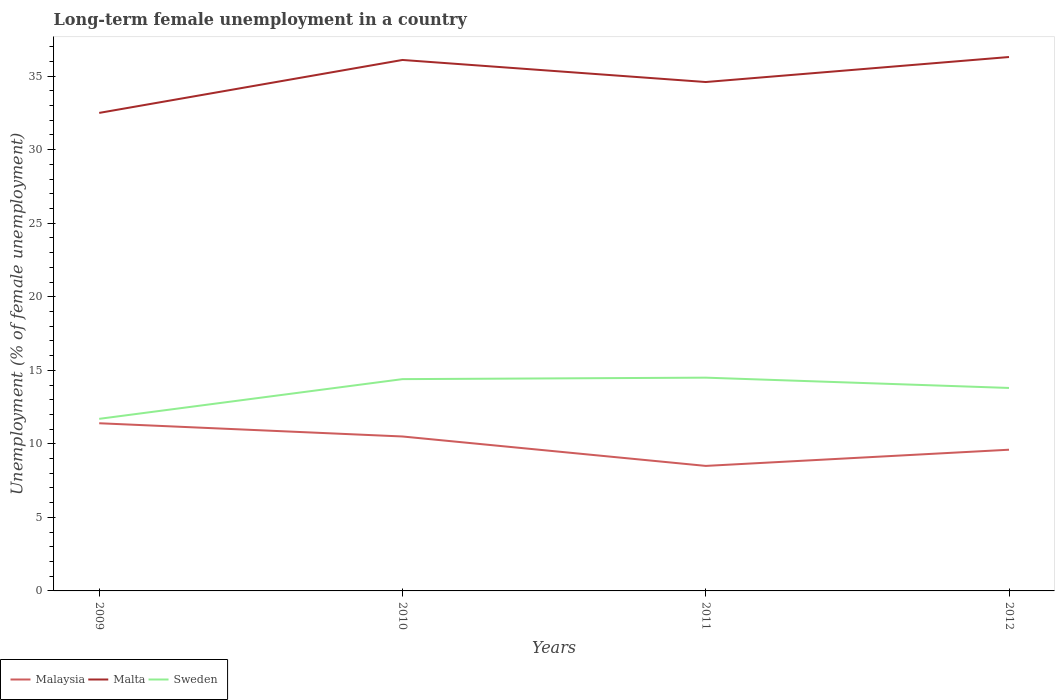Does the line corresponding to Malaysia intersect with the line corresponding to Malta?
Ensure brevity in your answer.  No. Is the number of lines equal to the number of legend labels?
Make the answer very short. Yes. Across all years, what is the maximum percentage of long-term unemployed female population in Malaysia?
Your answer should be compact. 8.5. In which year was the percentage of long-term unemployed female population in Malaysia maximum?
Offer a terse response. 2011. What is the total percentage of long-term unemployed female population in Sweden in the graph?
Provide a short and direct response. 0.7. What is the difference between the highest and the second highest percentage of long-term unemployed female population in Malta?
Ensure brevity in your answer.  3.8. What is the difference between the highest and the lowest percentage of long-term unemployed female population in Malaysia?
Give a very brief answer. 2. How many lines are there?
Give a very brief answer. 3. Are the values on the major ticks of Y-axis written in scientific E-notation?
Provide a short and direct response. No. Does the graph contain grids?
Make the answer very short. No. How are the legend labels stacked?
Your answer should be very brief. Horizontal. What is the title of the graph?
Your answer should be very brief. Long-term female unemployment in a country. Does "Samoa" appear as one of the legend labels in the graph?
Make the answer very short. No. What is the label or title of the X-axis?
Your response must be concise. Years. What is the label or title of the Y-axis?
Give a very brief answer. Unemployment (% of female unemployment). What is the Unemployment (% of female unemployment) in Malaysia in 2009?
Offer a terse response. 11.4. What is the Unemployment (% of female unemployment) of Malta in 2009?
Your answer should be very brief. 32.5. What is the Unemployment (% of female unemployment) of Sweden in 2009?
Ensure brevity in your answer.  11.7. What is the Unemployment (% of female unemployment) in Malta in 2010?
Make the answer very short. 36.1. What is the Unemployment (% of female unemployment) in Sweden in 2010?
Provide a succinct answer. 14.4. What is the Unemployment (% of female unemployment) of Malaysia in 2011?
Provide a succinct answer. 8.5. What is the Unemployment (% of female unemployment) in Malta in 2011?
Keep it short and to the point. 34.6. What is the Unemployment (% of female unemployment) of Malaysia in 2012?
Give a very brief answer. 9.6. What is the Unemployment (% of female unemployment) of Malta in 2012?
Your response must be concise. 36.3. What is the Unemployment (% of female unemployment) in Sweden in 2012?
Keep it short and to the point. 13.8. Across all years, what is the maximum Unemployment (% of female unemployment) in Malaysia?
Make the answer very short. 11.4. Across all years, what is the maximum Unemployment (% of female unemployment) in Malta?
Make the answer very short. 36.3. Across all years, what is the minimum Unemployment (% of female unemployment) in Malta?
Offer a terse response. 32.5. Across all years, what is the minimum Unemployment (% of female unemployment) of Sweden?
Give a very brief answer. 11.7. What is the total Unemployment (% of female unemployment) in Malta in the graph?
Make the answer very short. 139.5. What is the total Unemployment (% of female unemployment) in Sweden in the graph?
Give a very brief answer. 54.4. What is the difference between the Unemployment (% of female unemployment) of Malta in 2009 and that in 2010?
Provide a short and direct response. -3.6. What is the difference between the Unemployment (% of female unemployment) in Sweden in 2009 and that in 2010?
Keep it short and to the point. -2.7. What is the difference between the Unemployment (% of female unemployment) in Malaysia in 2009 and that in 2011?
Your response must be concise. 2.9. What is the difference between the Unemployment (% of female unemployment) in Malaysia in 2009 and that in 2012?
Give a very brief answer. 1.8. What is the difference between the Unemployment (% of female unemployment) of Sweden in 2009 and that in 2012?
Your answer should be very brief. -2.1. What is the difference between the Unemployment (% of female unemployment) in Malta in 2010 and that in 2011?
Ensure brevity in your answer.  1.5. What is the difference between the Unemployment (% of female unemployment) of Sweden in 2010 and that in 2011?
Your response must be concise. -0.1. What is the difference between the Unemployment (% of female unemployment) of Malta in 2010 and that in 2012?
Provide a succinct answer. -0.2. What is the difference between the Unemployment (% of female unemployment) of Malaysia in 2009 and the Unemployment (% of female unemployment) of Malta in 2010?
Offer a very short reply. -24.7. What is the difference between the Unemployment (% of female unemployment) in Malaysia in 2009 and the Unemployment (% of female unemployment) in Sweden in 2010?
Keep it short and to the point. -3. What is the difference between the Unemployment (% of female unemployment) of Malaysia in 2009 and the Unemployment (% of female unemployment) of Malta in 2011?
Ensure brevity in your answer.  -23.2. What is the difference between the Unemployment (% of female unemployment) in Malta in 2009 and the Unemployment (% of female unemployment) in Sweden in 2011?
Your answer should be compact. 18. What is the difference between the Unemployment (% of female unemployment) in Malaysia in 2009 and the Unemployment (% of female unemployment) in Malta in 2012?
Offer a terse response. -24.9. What is the difference between the Unemployment (% of female unemployment) of Malta in 2009 and the Unemployment (% of female unemployment) of Sweden in 2012?
Your answer should be compact. 18.7. What is the difference between the Unemployment (% of female unemployment) in Malaysia in 2010 and the Unemployment (% of female unemployment) in Malta in 2011?
Provide a short and direct response. -24.1. What is the difference between the Unemployment (% of female unemployment) of Malaysia in 2010 and the Unemployment (% of female unemployment) of Sweden in 2011?
Provide a short and direct response. -4. What is the difference between the Unemployment (% of female unemployment) in Malta in 2010 and the Unemployment (% of female unemployment) in Sweden in 2011?
Offer a very short reply. 21.6. What is the difference between the Unemployment (% of female unemployment) in Malaysia in 2010 and the Unemployment (% of female unemployment) in Malta in 2012?
Keep it short and to the point. -25.8. What is the difference between the Unemployment (% of female unemployment) of Malaysia in 2010 and the Unemployment (% of female unemployment) of Sweden in 2012?
Your answer should be compact. -3.3. What is the difference between the Unemployment (% of female unemployment) in Malta in 2010 and the Unemployment (% of female unemployment) in Sweden in 2012?
Your answer should be compact. 22.3. What is the difference between the Unemployment (% of female unemployment) of Malaysia in 2011 and the Unemployment (% of female unemployment) of Malta in 2012?
Offer a very short reply. -27.8. What is the difference between the Unemployment (% of female unemployment) in Malta in 2011 and the Unemployment (% of female unemployment) in Sweden in 2012?
Provide a succinct answer. 20.8. What is the average Unemployment (% of female unemployment) in Malta per year?
Your answer should be compact. 34.88. What is the average Unemployment (% of female unemployment) of Sweden per year?
Your answer should be very brief. 13.6. In the year 2009, what is the difference between the Unemployment (% of female unemployment) of Malaysia and Unemployment (% of female unemployment) of Malta?
Offer a terse response. -21.1. In the year 2009, what is the difference between the Unemployment (% of female unemployment) of Malta and Unemployment (% of female unemployment) of Sweden?
Provide a succinct answer. 20.8. In the year 2010, what is the difference between the Unemployment (% of female unemployment) of Malaysia and Unemployment (% of female unemployment) of Malta?
Your answer should be very brief. -25.6. In the year 2010, what is the difference between the Unemployment (% of female unemployment) in Malta and Unemployment (% of female unemployment) in Sweden?
Your answer should be very brief. 21.7. In the year 2011, what is the difference between the Unemployment (% of female unemployment) of Malaysia and Unemployment (% of female unemployment) of Malta?
Your response must be concise. -26.1. In the year 2011, what is the difference between the Unemployment (% of female unemployment) in Malta and Unemployment (% of female unemployment) in Sweden?
Provide a short and direct response. 20.1. In the year 2012, what is the difference between the Unemployment (% of female unemployment) in Malaysia and Unemployment (% of female unemployment) in Malta?
Provide a short and direct response. -26.7. In the year 2012, what is the difference between the Unemployment (% of female unemployment) in Malta and Unemployment (% of female unemployment) in Sweden?
Your answer should be very brief. 22.5. What is the ratio of the Unemployment (% of female unemployment) of Malaysia in 2009 to that in 2010?
Make the answer very short. 1.09. What is the ratio of the Unemployment (% of female unemployment) of Malta in 2009 to that in 2010?
Offer a terse response. 0.9. What is the ratio of the Unemployment (% of female unemployment) of Sweden in 2009 to that in 2010?
Give a very brief answer. 0.81. What is the ratio of the Unemployment (% of female unemployment) in Malaysia in 2009 to that in 2011?
Provide a short and direct response. 1.34. What is the ratio of the Unemployment (% of female unemployment) of Malta in 2009 to that in 2011?
Ensure brevity in your answer.  0.94. What is the ratio of the Unemployment (% of female unemployment) in Sweden in 2009 to that in 2011?
Offer a very short reply. 0.81. What is the ratio of the Unemployment (% of female unemployment) of Malaysia in 2009 to that in 2012?
Make the answer very short. 1.19. What is the ratio of the Unemployment (% of female unemployment) of Malta in 2009 to that in 2012?
Ensure brevity in your answer.  0.9. What is the ratio of the Unemployment (% of female unemployment) in Sweden in 2009 to that in 2012?
Your response must be concise. 0.85. What is the ratio of the Unemployment (% of female unemployment) in Malaysia in 2010 to that in 2011?
Your response must be concise. 1.24. What is the ratio of the Unemployment (% of female unemployment) in Malta in 2010 to that in 2011?
Make the answer very short. 1.04. What is the ratio of the Unemployment (% of female unemployment) of Malaysia in 2010 to that in 2012?
Your response must be concise. 1.09. What is the ratio of the Unemployment (% of female unemployment) of Sweden in 2010 to that in 2012?
Your answer should be very brief. 1.04. What is the ratio of the Unemployment (% of female unemployment) of Malaysia in 2011 to that in 2012?
Offer a very short reply. 0.89. What is the ratio of the Unemployment (% of female unemployment) in Malta in 2011 to that in 2012?
Give a very brief answer. 0.95. What is the ratio of the Unemployment (% of female unemployment) in Sweden in 2011 to that in 2012?
Keep it short and to the point. 1.05. What is the difference between the highest and the second highest Unemployment (% of female unemployment) in Malaysia?
Your response must be concise. 0.9. What is the difference between the highest and the second highest Unemployment (% of female unemployment) in Sweden?
Provide a succinct answer. 0.1. What is the difference between the highest and the lowest Unemployment (% of female unemployment) of Malta?
Provide a short and direct response. 3.8. What is the difference between the highest and the lowest Unemployment (% of female unemployment) in Sweden?
Offer a terse response. 2.8. 